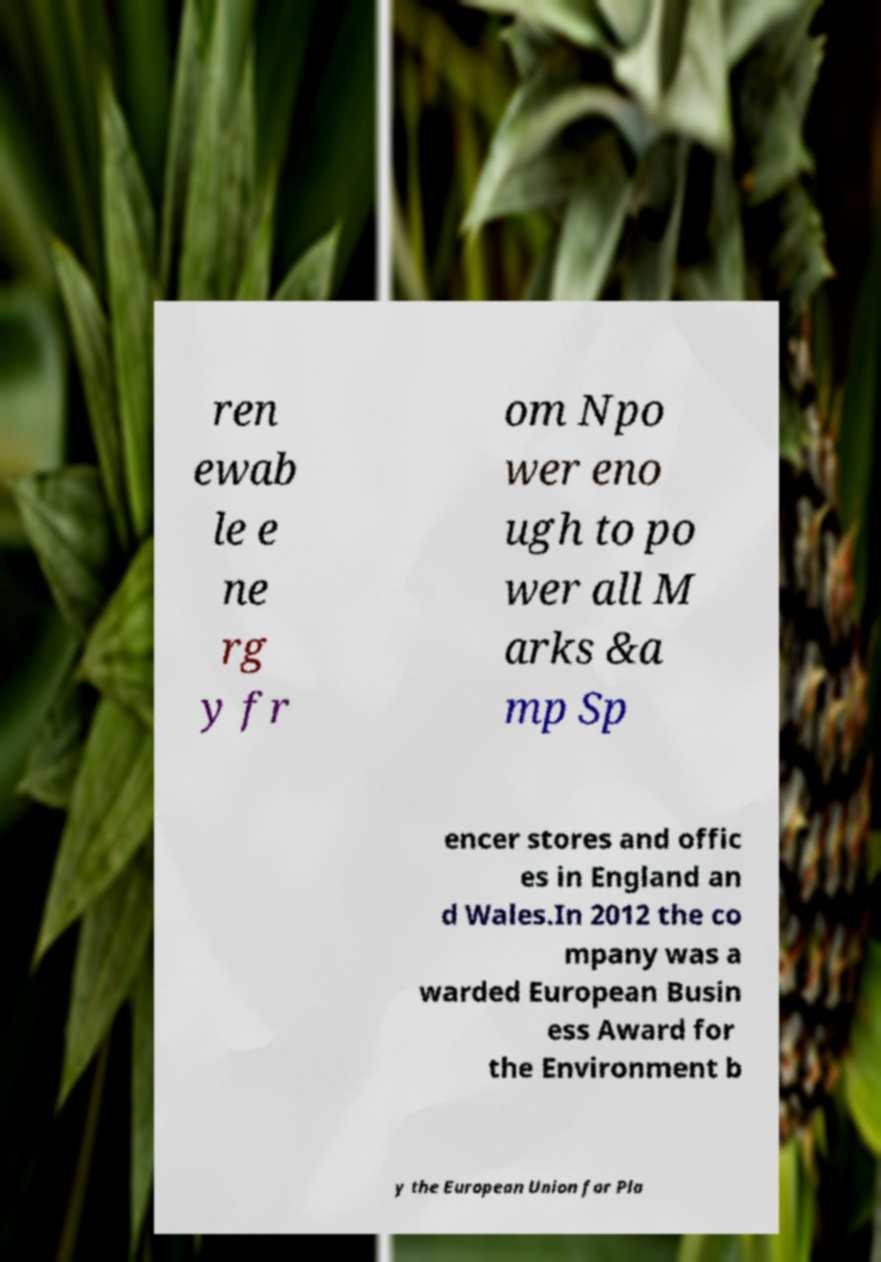Could you assist in decoding the text presented in this image and type it out clearly? ren ewab le e ne rg y fr om Npo wer eno ugh to po wer all M arks &a mp Sp encer stores and offic es in England an d Wales.In 2012 the co mpany was a warded European Busin ess Award for the Environment b y the European Union for Pla 